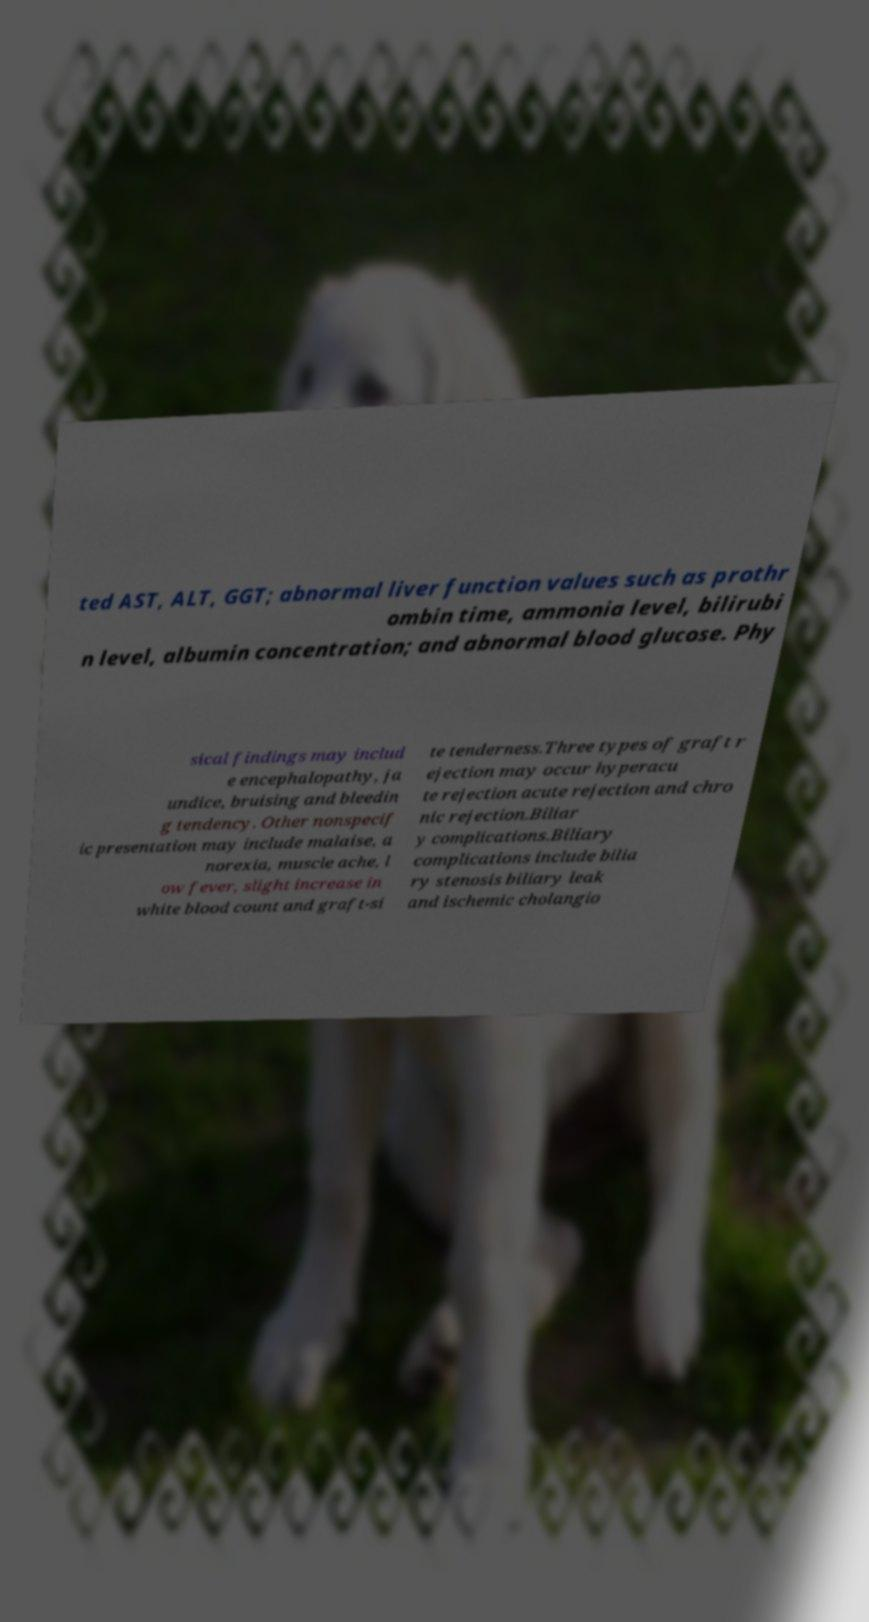There's text embedded in this image that I need extracted. Can you transcribe it verbatim? ted AST, ALT, GGT; abnormal liver function values such as prothr ombin time, ammonia level, bilirubi n level, albumin concentration; and abnormal blood glucose. Phy sical findings may includ e encephalopathy, ja undice, bruising and bleedin g tendency. Other nonspecif ic presentation may include malaise, a norexia, muscle ache, l ow fever, slight increase in white blood count and graft-si te tenderness.Three types of graft r ejection may occur hyperacu te rejection acute rejection and chro nic rejection.Biliar y complications.Biliary complications include bilia ry stenosis biliary leak and ischemic cholangio 